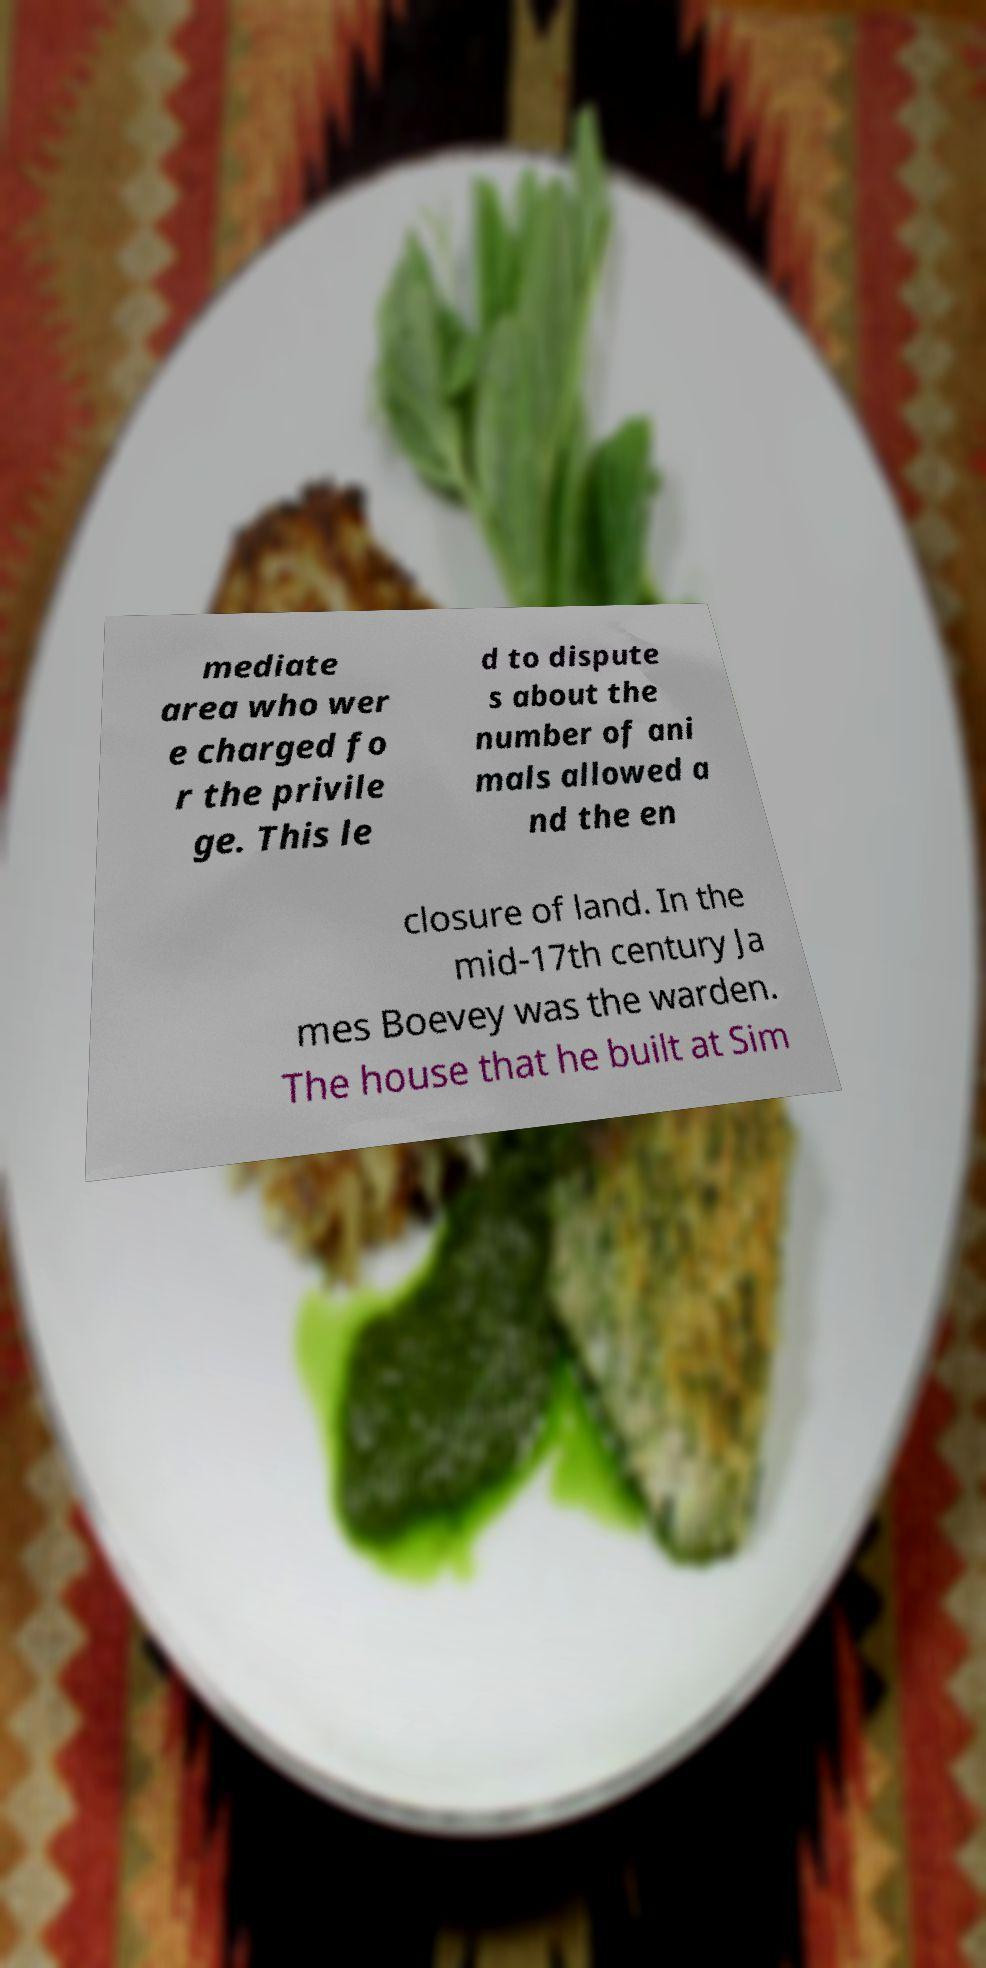There's text embedded in this image that I need extracted. Can you transcribe it verbatim? mediate area who wer e charged fo r the privile ge. This le d to dispute s about the number of ani mals allowed a nd the en closure of land. In the mid-17th century Ja mes Boevey was the warden. The house that he built at Sim 